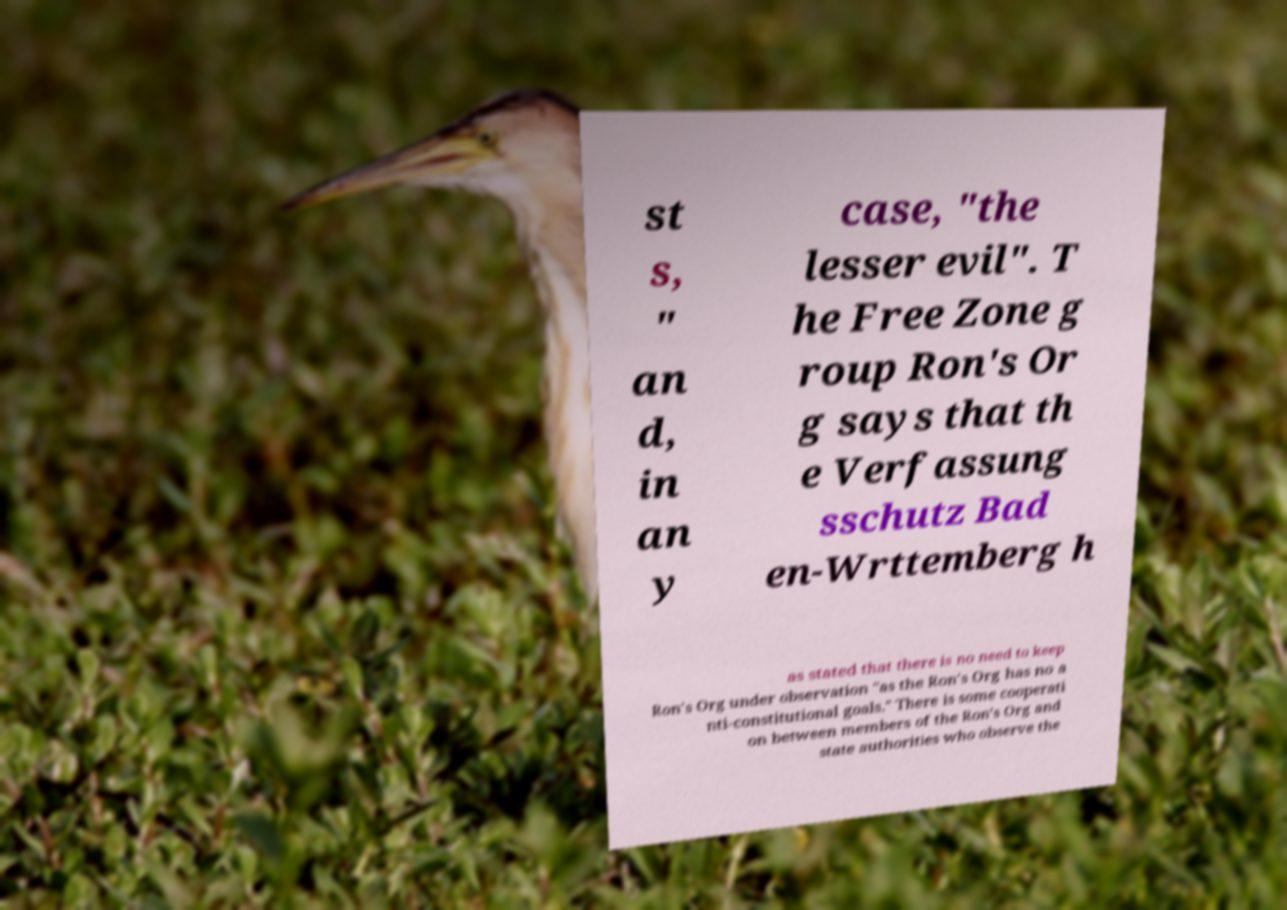Can you accurately transcribe the text from the provided image for me? st s, " an d, in an y case, "the lesser evil". T he Free Zone g roup Ron's Or g says that th e Verfassung sschutz Bad en-Wrttemberg h as stated that there is no need to keep Ron's Org under observation "as the Ron's Org has no a nti-constitutional goals." There is some cooperati on between members of the Ron's Org and state authorities who observe the 